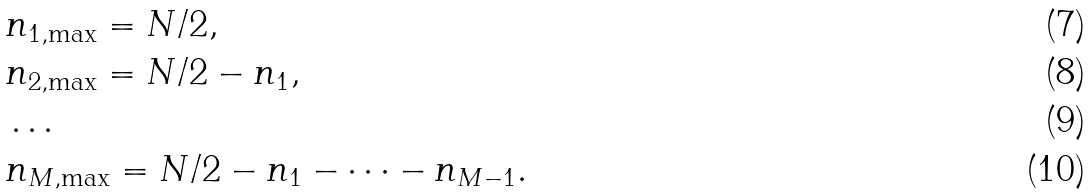Convert formula to latex. <formula><loc_0><loc_0><loc_500><loc_500>& n _ { 1 , \max } = N / 2 , \\ & n _ { 2 , \max } = N / 2 - n _ { 1 } , \\ & \dots \\ & n _ { M , \max } = N / 2 - n _ { 1 } - \cdots - n _ { M - 1 } .</formula> 